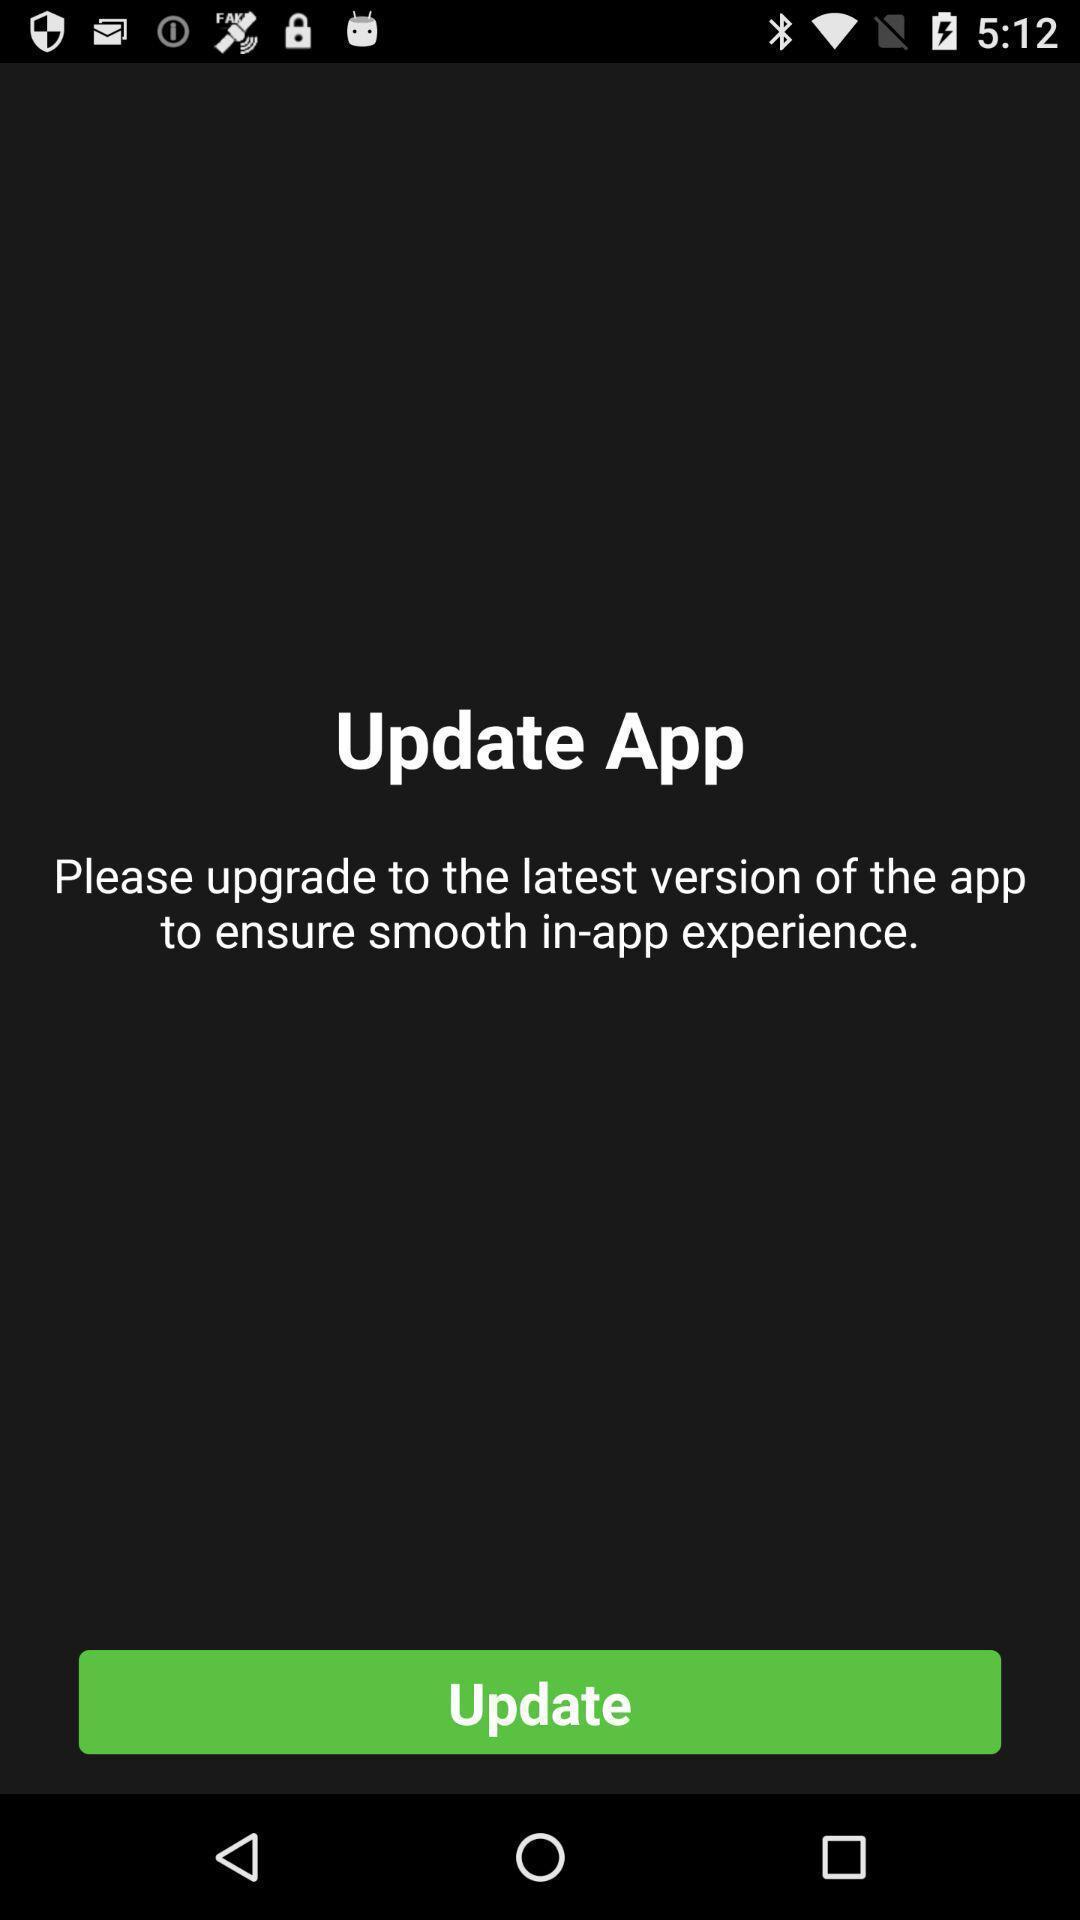Describe the visual elements of this screenshot. Screen showing update app with option. 